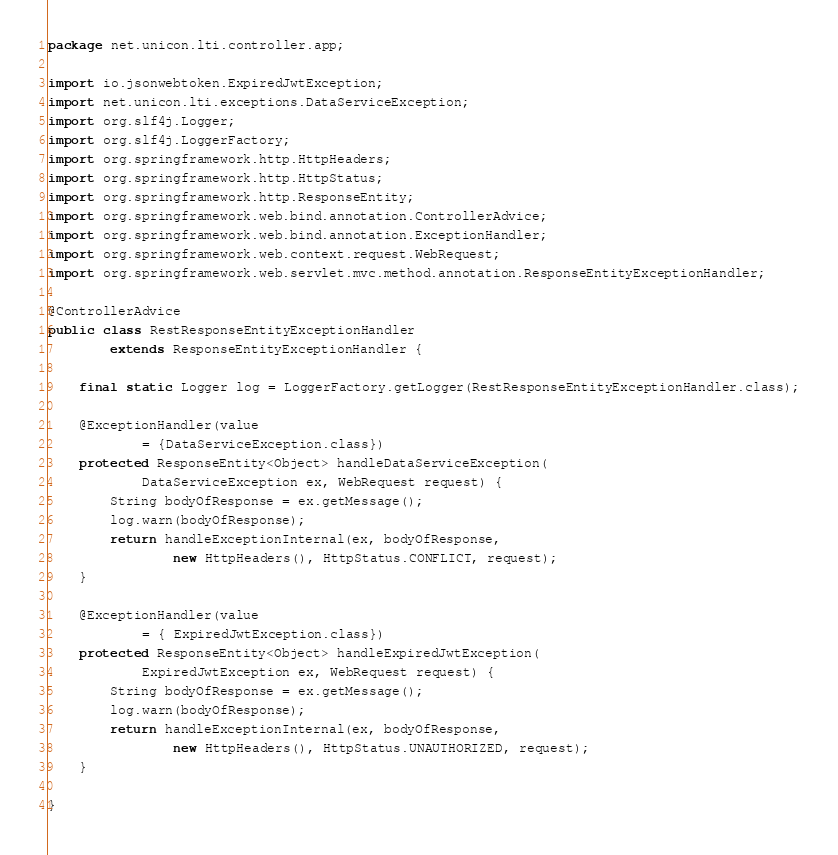<code> <loc_0><loc_0><loc_500><loc_500><_Java_>package net.unicon.lti.controller.app;

import io.jsonwebtoken.ExpiredJwtException;
import net.unicon.lti.exceptions.DataServiceException;
import org.slf4j.Logger;
import org.slf4j.LoggerFactory;
import org.springframework.http.HttpHeaders;
import org.springframework.http.HttpStatus;
import org.springframework.http.ResponseEntity;
import org.springframework.web.bind.annotation.ControllerAdvice;
import org.springframework.web.bind.annotation.ExceptionHandler;
import org.springframework.web.context.request.WebRequest;
import org.springframework.web.servlet.mvc.method.annotation.ResponseEntityExceptionHandler;

@ControllerAdvice
public class RestResponseEntityExceptionHandler
        extends ResponseEntityExceptionHandler {

    final static Logger log = LoggerFactory.getLogger(RestResponseEntityExceptionHandler.class);

    @ExceptionHandler(value
            = {DataServiceException.class})
    protected ResponseEntity<Object> handleDataServiceException(
            DataServiceException ex, WebRequest request) {
        String bodyOfResponse = ex.getMessage();
        log.warn(bodyOfResponse);
        return handleExceptionInternal(ex, bodyOfResponse,
                new HttpHeaders(), HttpStatus.CONFLICT, request);
    }

    @ExceptionHandler(value
            = { ExpiredJwtException.class})
    protected ResponseEntity<Object> handleExpiredJwtException(
            ExpiredJwtException ex, WebRequest request) {
        String bodyOfResponse = ex.getMessage();
        log.warn(bodyOfResponse);
        return handleExceptionInternal(ex, bodyOfResponse,
                new HttpHeaders(), HttpStatus.UNAUTHORIZED, request);
    }

}
</code> 